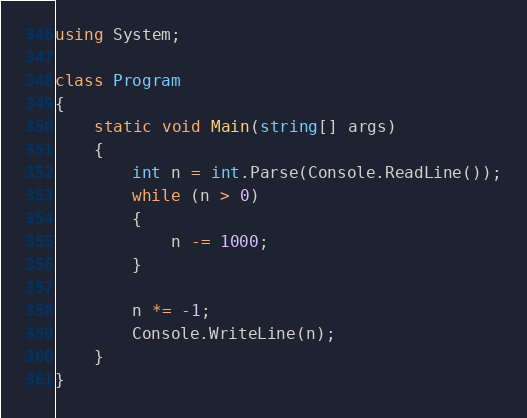<code> <loc_0><loc_0><loc_500><loc_500><_C#_>using System;

class Program
{
    static void Main(string[] args)
    {
        int n = int.Parse(Console.ReadLine());
        while (n > 0)
        {
            n -= 1000;
        }

        n *= -1;
        Console.WriteLine(n);
    }
}
</code> 